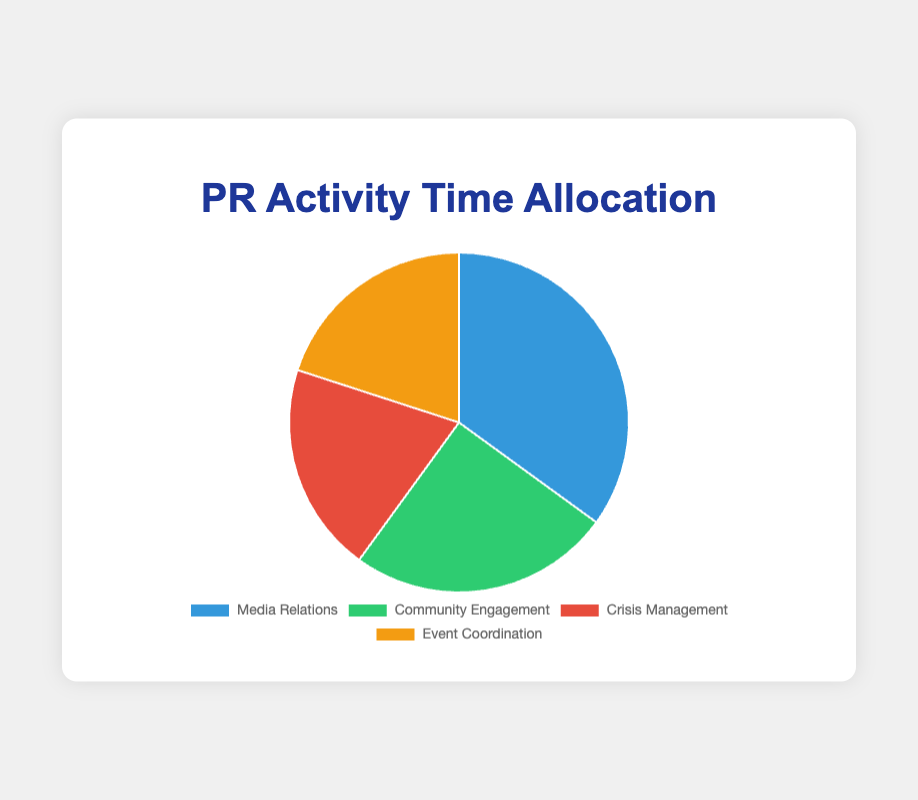What is the activity with the highest time allocation? The activity with the highest time allocation can be identified by looking at the segment that occupies the largest portion of the pie chart. The largest segment in the pie chart represents Media Relations.
Answer: Media Relations Which two activities have the same percentage of time allocation? By observing the pie chart, you can see that both the segments for Crisis Management and Event Coordination are of the same size, each representing a 20% allocation.
Answer: Crisis Management and Event Coordination What percentage of time is allocated to activities related to external communication (Media Relations and Community Engagement)? Add the percentages of Media Relations (35%) and Community Engagement (25%): 35% + 25% = 60%. This is the total percentage allocated to activities related to external communication.
Answer: 60% Which activities take up less than a quarter of the total time? By examining the pie chart, the segments for Crisis Management (20%) and Event Coordination (20%) each represent less than 25% of the total time.
Answer: Crisis Management and Event Coordination How much more time is allocated to Media Relations compared to Crisis Management? To find this, subtract the percentage of time allocated to Crisis Management (20%) from that allocated to Media Relations (35%): 35% - 20% = 15%.
Answer: 15% What is the combined time allocation for internal activities (Crisis Management and Event Coordination)? Add the percentages for Crisis Management (20%) and Event Coordination (20%): 20% + 20% = 40%.
Answer: 40% Which activity is represented by the green segment in the pie chart? The green color in the pie chart corresponds to the segment that represents Community Engagement.
Answer: Community Engagement Is there a significant difference between the time allocated to Community Engagement and Event Coordination? Compare the percentages of Community Engagement (25%) and Event Coordination (20%). The difference is 25% - 20% = 5%, which is not significant.
Answer: No What is the average percentage of time allocated to all activities? To find the average, add the percentages of all activities and divide by the number of activities: (35% + 25% + 20% + 20%) / 4 = 100% / 4 = 25%.
Answer: 25% What is the ratio of time allocated to Media Relations compared to Crisis Management? The time allocation ratio is found by dividing the percentage for Media Relations (35%) by the percentage for Crisis Management (20%): 35% ÷ 20% = 1.75.
Answer: 1.75:1 